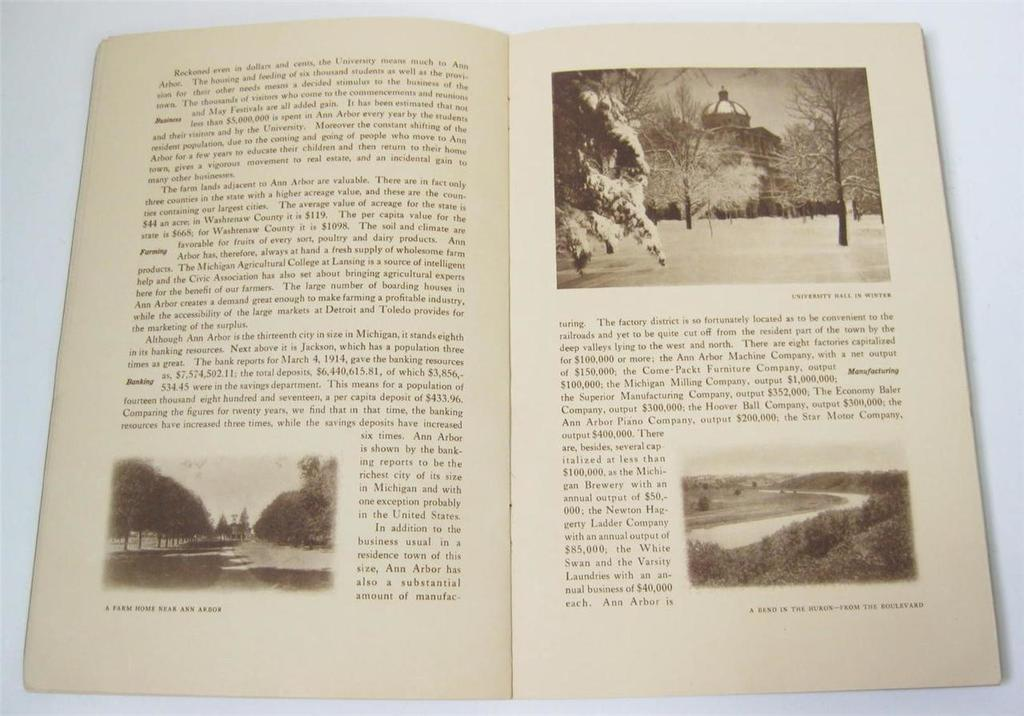What is placed on the platform in the image? There is a book on a platform. What type of content is featured in the book? The book contains pictures of trees, buildings, and plants. Is there any text written on the book? Yes, there is text written on the book. What type of insurance policy is mentioned in the book? There is no mention of insurance policies in the book, as it contains pictures of trees, buildings, and plants, along with text. What type of cloth is used to cover the book? There is no cloth present in the image, and the book is not covered. 